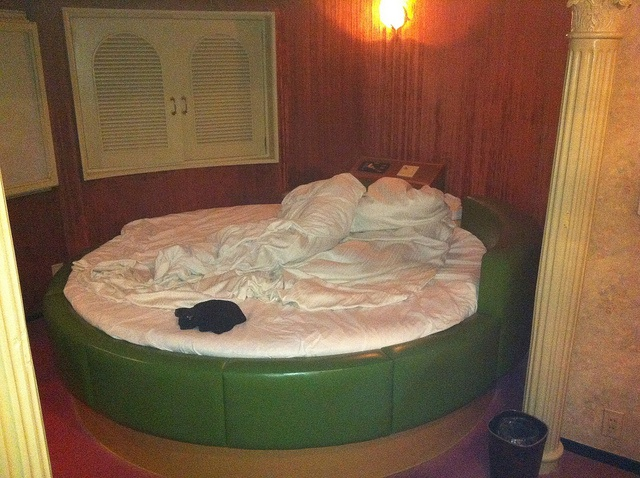Describe the objects in this image and their specific colors. I can see a bed in black and tan tones in this image. 